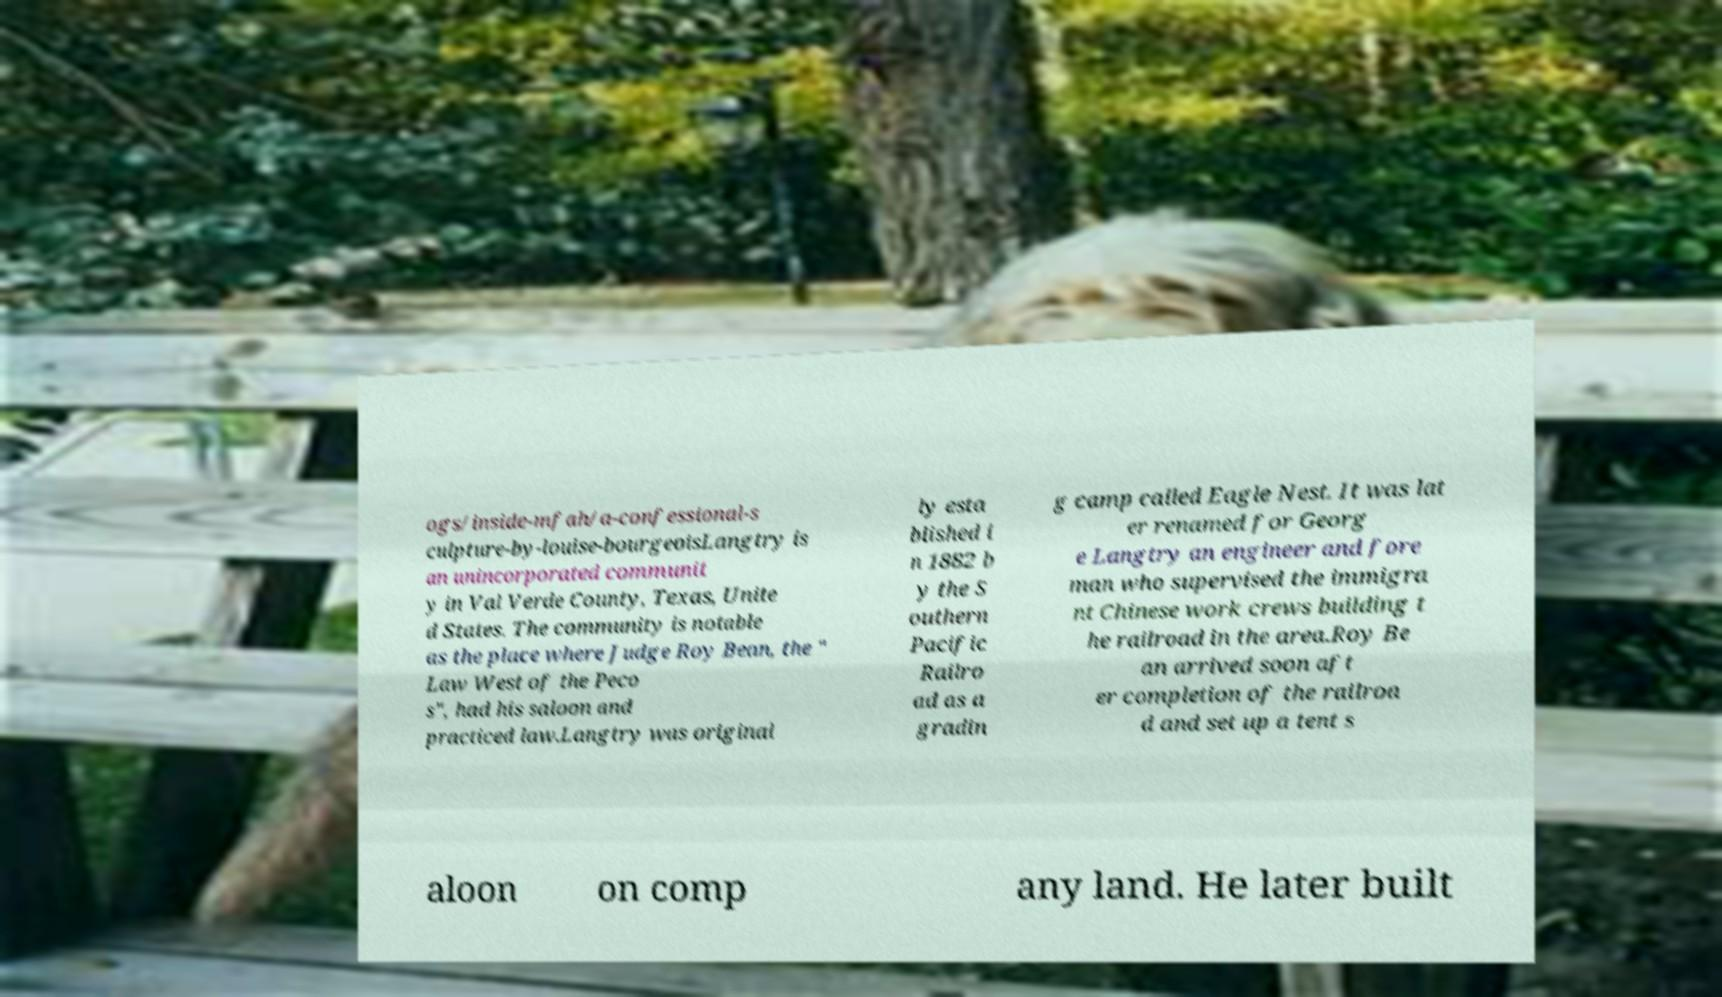Can you accurately transcribe the text from the provided image for me? ogs/inside-mfah/a-confessional-s culpture-by-louise-bourgeoisLangtry is an unincorporated communit y in Val Verde County, Texas, Unite d States. The community is notable as the place where Judge Roy Bean, the " Law West of the Peco s", had his saloon and practiced law.Langtry was original ly esta blished i n 1882 b y the S outhern Pacific Railro ad as a gradin g camp called Eagle Nest. It was lat er renamed for Georg e Langtry an engineer and fore man who supervised the immigra nt Chinese work crews building t he railroad in the area.Roy Be an arrived soon aft er completion of the railroa d and set up a tent s aloon on comp any land. He later built 